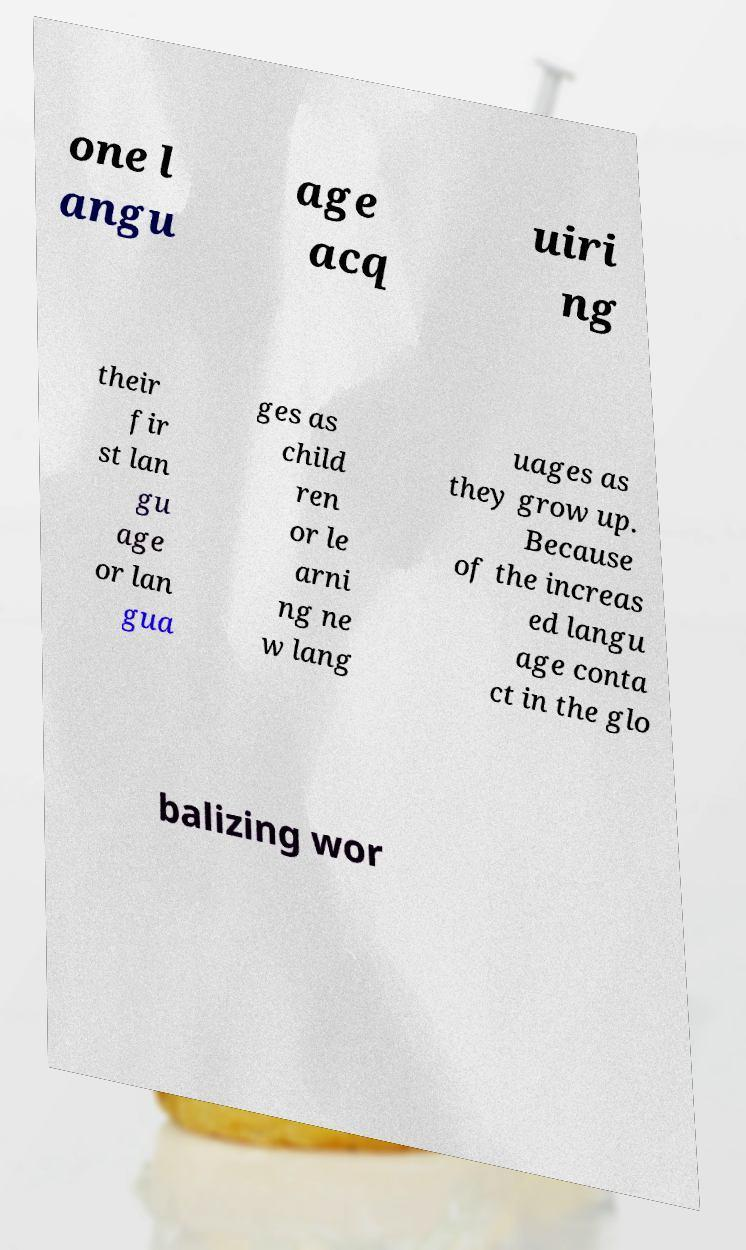There's text embedded in this image that I need extracted. Can you transcribe it verbatim? one l angu age acq uiri ng their fir st lan gu age or lan gua ges as child ren or le arni ng ne w lang uages as they grow up. Because of the increas ed langu age conta ct in the glo balizing wor 